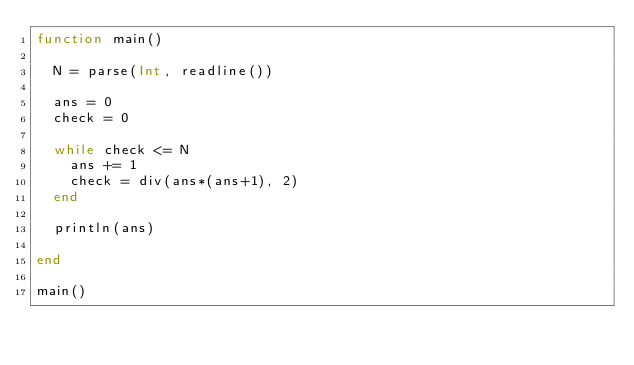<code> <loc_0><loc_0><loc_500><loc_500><_Julia_>function main()
  
  N = parse(Int, readline())
  
  ans = 0
  check = 0
  
  while check <= N
    ans += 1
    check = div(ans*(ans+1), 2)
  end
  
  println(ans)
  
end

main()</code> 